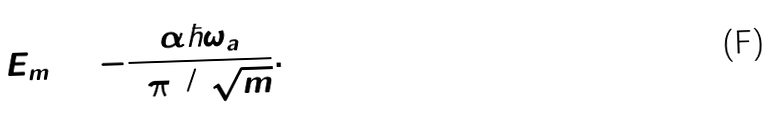Convert formula to latex. <formula><loc_0><loc_0><loc_500><loc_500>E _ { m } = - \frac { \alpha \hbar { \omega } _ { a } } { 8 \pi ^ { 3 / 2 } \sqrt { m } } .</formula> 